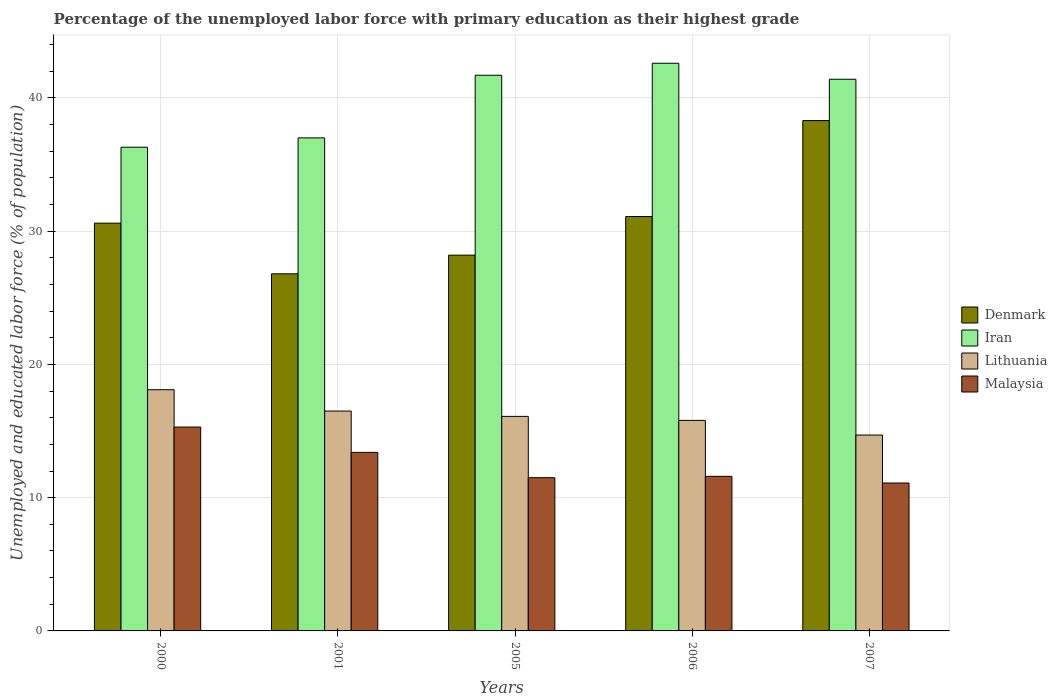How many groups of bars are there?
Your response must be concise. 5. Are the number of bars per tick equal to the number of legend labels?
Give a very brief answer. Yes. How many bars are there on the 4th tick from the left?
Provide a short and direct response. 4. How many bars are there on the 5th tick from the right?
Keep it short and to the point. 4. In how many cases, is the number of bars for a given year not equal to the number of legend labels?
Provide a succinct answer. 0. What is the percentage of the unemployed labor force with primary education in Denmark in 2001?
Give a very brief answer. 26.8. Across all years, what is the maximum percentage of the unemployed labor force with primary education in Malaysia?
Your response must be concise. 15.3. Across all years, what is the minimum percentage of the unemployed labor force with primary education in Iran?
Offer a terse response. 36.3. In which year was the percentage of the unemployed labor force with primary education in Denmark minimum?
Your answer should be very brief. 2001. What is the total percentage of the unemployed labor force with primary education in Denmark in the graph?
Your response must be concise. 155. What is the difference between the percentage of the unemployed labor force with primary education in Lithuania in 2005 and that in 2007?
Offer a very short reply. 1.4. What is the difference between the percentage of the unemployed labor force with primary education in Iran in 2005 and the percentage of the unemployed labor force with primary education in Malaysia in 2001?
Provide a short and direct response. 28.3. What is the average percentage of the unemployed labor force with primary education in Malaysia per year?
Keep it short and to the point. 12.58. In the year 2005, what is the difference between the percentage of the unemployed labor force with primary education in Malaysia and percentage of the unemployed labor force with primary education in Denmark?
Ensure brevity in your answer.  -16.7. What is the ratio of the percentage of the unemployed labor force with primary education in Malaysia in 2006 to that in 2007?
Your answer should be very brief. 1.05. Is the percentage of the unemployed labor force with primary education in Denmark in 2000 less than that in 2001?
Provide a succinct answer. No. What is the difference between the highest and the second highest percentage of the unemployed labor force with primary education in Lithuania?
Your response must be concise. 1.6. What is the difference between the highest and the lowest percentage of the unemployed labor force with primary education in Iran?
Ensure brevity in your answer.  6.3. Is it the case that in every year, the sum of the percentage of the unemployed labor force with primary education in Lithuania and percentage of the unemployed labor force with primary education in Denmark is greater than the sum of percentage of the unemployed labor force with primary education in Malaysia and percentage of the unemployed labor force with primary education in Iran?
Provide a succinct answer. No. What does the 3rd bar from the left in 2006 represents?
Keep it short and to the point. Lithuania. Is it the case that in every year, the sum of the percentage of the unemployed labor force with primary education in Malaysia and percentage of the unemployed labor force with primary education in Lithuania is greater than the percentage of the unemployed labor force with primary education in Denmark?
Offer a terse response. No. Are all the bars in the graph horizontal?
Your response must be concise. No. What is the difference between two consecutive major ticks on the Y-axis?
Offer a terse response. 10. Are the values on the major ticks of Y-axis written in scientific E-notation?
Keep it short and to the point. No. How are the legend labels stacked?
Keep it short and to the point. Vertical. What is the title of the graph?
Keep it short and to the point. Percentage of the unemployed labor force with primary education as their highest grade. Does "Guinea" appear as one of the legend labels in the graph?
Provide a succinct answer. No. What is the label or title of the X-axis?
Give a very brief answer. Years. What is the label or title of the Y-axis?
Give a very brief answer. Unemployed and educated labor force (% of population). What is the Unemployed and educated labor force (% of population) in Denmark in 2000?
Offer a terse response. 30.6. What is the Unemployed and educated labor force (% of population) of Iran in 2000?
Provide a short and direct response. 36.3. What is the Unemployed and educated labor force (% of population) in Lithuania in 2000?
Give a very brief answer. 18.1. What is the Unemployed and educated labor force (% of population) in Malaysia in 2000?
Your answer should be very brief. 15.3. What is the Unemployed and educated labor force (% of population) in Denmark in 2001?
Make the answer very short. 26.8. What is the Unemployed and educated labor force (% of population) of Iran in 2001?
Provide a short and direct response. 37. What is the Unemployed and educated labor force (% of population) in Malaysia in 2001?
Your response must be concise. 13.4. What is the Unemployed and educated labor force (% of population) in Denmark in 2005?
Your response must be concise. 28.2. What is the Unemployed and educated labor force (% of population) of Iran in 2005?
Give a very brief answer. 41.7. What is the Unemployed and educated labor force (% of population) in Lithuania in 2005?
Offer a terse response. 16.1. What is the Unemployed and educated labor force (% of population) of Denmark in 2006?
Your answer should be very brief. 31.1. What is the Unemployed and educated labor force (% of population) in Iran in 2006?
Provide a short and direct response. 42.6. What is the Unemployed and educated labor force (% of population) in Lithuania in 2006?
Provide a succinct answer. 15.8. What is the Unemployed and educated labor force (% of population) in Malaysia in 2006?
Your answer should be very brief. 11.6. What is the Unemployed and educated labor force (% of population) in Denmark in 2007?
Offer a terse response. 38.3. What is the Unemployed and educated labor force (% of population) of Iran in 2007?
Your response must be concise. 41.4. What is the Unemployed and educated labor force (% of population) in Lithuania in 2007?
Provide a succinct answer. 14.7. What is the Unemployed and educated labor force (% of population) of Malaysia in 2007?
Your response must be concise. 11.1. Across all years, what is the maximum Unemployed and educated labor force (% of population) in Denmark?
Provide a succinct answer. 38.3. Across all years, what is the maximum Unemployed and educated labor force (% of population) of Iran?
Your answer should be very brief. 42.6. Across all years, what is the maximum Unemployed and educated labor force (% of population) of Lithuania?
Provide a succinct answer. 18.1. Across all years, what is the maximum Unemployed and educated labor force (% of population) in Malaysia?
Make the answer very short. 15.3. Across all years, what is the minimum Unemployed and educated labor force (% of population) in Denmark?
Your response must be concise. 26.8. Across all years, what is the minimum Unemployed and educated labor force (% of population) in Iran?
Make the answer very short. 36.3. Across all years, what is the minimum Unemployed and educated labor force (% of population) of Lithuania?
Make the answer very short. 14.7. Across all years, what is the minimum Unemployed and educated labor force (% of population) in Malaysia?
Ensure brevity in your answer.  11.1. What is the total Unemployed and educated labor force (% of population) of Denmark in the graph?
Ensure brevity in your answer.  155. What is the total Unemployed and educated labor force (% of population) of Iran in the graph?
Provide a short and direct response. 199. What is the total Unemployed and educated labor force (% of population) of Lithuania in the graph?
Your response must be concise. 81.2. What is the total Unemployed and educated labor force (% of population) in Malaysia in the graph?
Give a very brief answer. 62.9. What is the difference between the Unemployed and educated labor force (% of population) in Lithuania in 2000 and that in 2001?
Provide a short and direct response. 1.6. What is the difference between the Unemployed and educated labor force (% of population) in Malaysia in 2000 and that in 2001?
Make the answer very short. 1.9. What is the difference between the Unemployed and educated labor force (% of population) in Denmark in 2000 and that in 2005?
Provide a short and direct response. 2.4. What is the difference between the Unemployed and educated labor force (% of population) in Malaysia in 2000 and that in 2005?
Make the answer very short. 3.8. What is the difference between the Unemployed and educated labor force (% of population) in Denmark in 2000 and that in 2006?
Provide a short and direct response. -0.5. What is the difference between the Unemployed and educated labor force (% of population) in Iran in 2001 and that in 2005?
Ensure brevity in your answer.  -4.7. What is the difference between the Unemployed and educated labor force (% of population) of Iran in 2001 and that in 2006?
Keep it short and to the point. -5.6. What is the difference between the Unemployed and educated labor force (% of population) of Denmark in 2005 and that in 2006?
Make the answer very short. -2.9. What is the difference between the Unemployed and educated labor force (% of population) in Iran in 2005 and that in 2006?
Offer a very short reply. -0.9. What is the difference between the Unemployed and educated labor force (% of population) of Lithuania in 2005 and that in 2006?
Offer a very short reply. 0.3. What is the difference between the Unemployed and educated labor force (% of population) of Denmark in 2005 and that in 2007?
Keep it short and to the point. -10.1. What is the difference between the Unemployed and educated labor force (% of population) of Iran in 2005 and that in 2007?
Your answer should be compact. 0.3. What is the difference between the Unemployed and educated labor force (% of population) in Lithuania in 2005 and that in 2007?
Your answer should be compact. 1.4. What is the difference between the Unemployed and educated labor force (% of population) in Malaysia in 2005 and that in 2007?
Ensure brevity in your answer.  0.4. What is the difference between the Unemployed and educated labor force (% of population) of Denmark in 2006 and that in 2007?
Provide a short and direct response. -7.2. What is the difference between the Unemployed and educated labor force (% of population) in Denmark in 2000 and the Unemployed and educated labor force (% of population) in Iran in 2001?
Provide a succinct answer. -6.4. What is the difference between the Unemployed and educated labor force (% of population) in Denmark in 2000 and the Unemployed and educated labor force (% of population) in Lithuania in 2001?
Provide a succinct answer. 14.1. What is the difference between the Unemployed and educated labor force (% of population) in Iran in 2000 and the Unemployed and educated labor force (% of population) in Lithuania in 2001?
Offer a very short reply. 19.8. What is the difference between the Unemployed and educated labor force (% of population) in Iran in 2000 and the Unemployed and educated labor force (% of population) in Malaysia in 2001?
Give a very brief answer. 22.9. What is the difference between the Unemployed and educated labor force (% of population) in Denmark in 2000 and the Unemployed and educated labor force (% of population) in Malaysia in 2005?
Provide a succinct answer. 19.1. What is the difference between the Unemployed and educated labor force (% of population) in Iran in 2000 and the Unemployed and educated labor force (% of population) in Lithuania in 2005?
Give a very brief answer. 20.2. What is the difference between the Unemployed and educated labor force (% of population) of Iran in 2000 and the Unemployed and educated labor force (% of population) of Malaysia in 2005?
Your response must be concise. 24.8. What is the difference between the Unemployed and educated labor force (% of population) in Lithuania in 2000 and the Unemployed and educated labor force (% of population) in Malaysia in 2005?
Ensure brevity in your answer.  6.6. What is the difference between the Unemployed and educated labor force (% of population) of Denmark in 2000 and the Unemployed and educated labor force (% of population) of Iran in 2006?
Your answer should be very brief. -12. What is the difference between the Unemployed and educated labor force (% of population) in Denmark in 2000 and the Unemployed and educated labor force (% of population) in Lithuania in 2006?
Offer a very short reply. 14.8. What is the difference between the Unemployed and educated labor force (% of population) of Iran in 2000 and the Unemployed and educated labor force (% of population) of Lithuania in 2006?
Offer a terse response. 20.5. What is the difference between the Unemployed and educated labor force (% of population) of Iran in 2000 and the Unemployed and educated labor force (% of population) of Malaysia in 2006?
Make the answer very short. 24.7. What is the difference between the Unemployed and educated labor force (% of population) in Lithuania in 2000 and the Unemployed and educated labor force (% of population) in Malaysia in 2006?
Provide a short and direct response. 6.5. What is the difference between the Unemployed and educated labor force (% of population) of Iran in 2000 and the Unemployed and educated labor force (% of population) of Lithuania in 2007?
Ensure brevity in your answer.  21.6. What is the difference between the Unemployed and educated labor force (% of population) of Iran in 2000 and the Unemployed and educated labor force (% of population) of Malaysia in 2007?
Ensure brevity in your answer.  25.2. What is the difference between the Unemployed and educated labor force (% of population) in Denmark in 2001 and the Unemployed and educated labor force (% of population) in Iran in 2005?
Your answer should be compact. -14.9. What is the difference between the Unemployed and educated labor force (% of population) in Denmark in 2001 and the Unemployed and educated labor force (% of population) in Lithuania in 2005?
Your answer should be compact. 10.7. What is the difference between the Unemployed and educated labor force (% of population) in Iran in 2001 and the Unemployed and educated labor force (% of population) in Lithuania in 2005?
Offer a very short reply. 20.9. What is the difference between the Unemployed and educated labor force (% of population) of Iran in 2001 and the Unemployed and educated labor force (% of population) of Malaysia in 2005?
Offer a terse response. 25.5. What is the difference between the Unemployed and educated labor force (% of population) in Denmark in 2001 and the Unemployed and educated labor force (% of population) in Iran in 2006?
Provide a succinct answer. -15.8. What is the difference between the Unemployed and educated labor force (% of population) of Denmark in 2001 and the Unemployed and educated labor force (% of population) of Malaysia in 2006?
Provide a succinct answer. 15.2. What is the difference between the Unemployed and educated labor force (% of population) in Iran in 2001 and the Unemployed and educated labor force (% of population) in Lithuania in 2006?
Your response must be concise. 21.2. What is the difference between the Unemployed and educated labor force (% of population) of Iran in 2001 and the Unemployed and educated labor force (% of population) of Malaysia in 2006?
Make the answer very short. 25.4. What is the difference between the Unemployed and educated labor force (% of population) of Lithuania in 2001 and the Unemployed and educated labor force (% of population) of Malaysia in 2006?
Offer a terse response. 4.9. What is the difference between the Unemployed and educated labor force (% of population) of Denmark in 2001 and the Unemployed and educated labor force (% of population) of Iran in 2007?
Ensure brevity in your answer.  -14.6. What is the difference between the Unemployed and educated labor force (% of population) in Denmark in 2001 and the Unemployed and educated labor force (% of population) in Lithuania in 2007?
Provide a short and direct response. 12.1. What is the difference between the Unemployed and educated labor force (% of population) in Iran in 2001 and the Unemployed and educated labor force (% of population) in Lithuania in 2007?
Your answer should be compact. 22.3. What is the difference between the Unemployed and educated labor force (% of population) of Iran in 2001 and the Unemployed and educated labor force (% of population) of Malaysia in 2007?
Offer a very short reply. 25.9. What is the difference between the Unemployed and educated labor force (% of population) in Denmark in 2005 and the Unemployed and educated labor force (% of population) in Iran in 2006?
Ensure brevity in your answer.  -14.4. What is the difference between the Unemployed and educated labor force (% of population) of Denmark in 2005 and the Unemployed and educated labor force (% of population) of Lithuania in 2006?
Keep it short and to the point. 12.4. What is the difference between the Unemployed and educated labor force (% of population) in Denmark in 2005 and the Unemployed and educated labor force (% of population) in Malaysia in 2006?
Keep it short and to the point. 16.6. What is the difference between the Unemployed and educated labor force (% of population) of Iran in 2005 and the Unemployed and educated labor force (% of population) of Lithuania in 2006?
Your answer should be compact. 25.9. What is the difference between the Unemployed and educated labor force (% of population) in Iran in 2005 and the Unemployed and educated labor force (% of population) in Malaysia in 2006?
Your answer should be very brief. 30.1. What is the difference between the Unemployed and educated labor force (% of population) in Iran in 2005 and the Unemployed and educated labor force (% of population) in Lithuania in 2007?
Ensure brevity in your answer.  27. What is the difference between the Unemployed and educated labor force (% of population) in Iran in 2005 and the Unemployed and educated labor force (% of population) in Malaysia in 2007?
Your response must be concise. 30.6. What is the difference between the Unemployed and educated labor force (% of population) in Denmark in 2006 and the Unemployed and educated labor force (% of population) in Lithuania in 2007?
Keep it short and to the point. 16.4. What is the difference between the Unemployed and educated labor force (% of population) in Iran in 2006 and the Unemployed and educated labor force (% of population) in Lithuania in 2007?
Ensure brevity in your answer.  27.9. What is the difference between the Unemployed and educated labor force (% of population) in Iran in 2006 and the Unemployed and educated labor force (% of population) in Malaysia in 2007?
Your response must be concise. 31.5. What is the difference between the Unemployed and educated labor force (% of population) in Lithuania in 2006 and the Unemployed and educated labor force (% of population) in Malaysia in 2007?
Offer a terse response. 4.7. What is the average Unemployed and educated labor force (% of population) in Denmark per year?
Offer a terse response. 31. What is the average Unemployed and educated labor force (% of population) of Iran per year?
Make the answer very short. 39.8. What is the average Unemployed and educated labor force (% of population) of Lithuania per year?
Ensure brevity in your answer.  16.24. What is the average Unemployed and educated labor force (% of population) of Malaysia per year?
Provide a short and direct response. 12.58. In the year 2000, what is the difference between the Unemployed and educated labor force (% of population) in Iran and Unemployed and educated labor force (% of population) in Malaysia?
Offer a terse response. 21. In the year 2001, what is the difference between the Unemployed and educated labor force (% of population) of Denmark and Unemployed and educated labor force (% of population) of Iran?
Your answer should be compact. -10.2. In the year 2001, what is the difference between the Unemployed and educated labor force (% of population) of Denmark and Unemployed and educated labor force (% of population) of Lithuania?
Provide a succinct answer. 10.3. In the year 2001, what is the difference between the Unemployed and educated labor force (% of population) in Iran and Unemployed and educated labor force (% of population) in Malaysia?
Offer a very short reply. 23.6. In the year 2001, what is the difference between the Unemployed and educated labor force (% of population) in Lithuania and Unemployed and educated labor force (% of population) in Malaysia?
Your response must be concise. 3.1. In the year 2005, what is the difference between the Unemployed and educated labor force (% of population) of Iran and Unemployed and educated labor force (% of population) of Lithuania?
Ensure brevity in your answer.  25.6. In the year 2005, what is the difference between the Unemployed and educated labor force (% of population) of Iran and Unemployed and educated labor force (% of population) of Malaysia?
Your response must be concise. 30.2. In the year 2006, what is the difference between the Unemployed and educated labor force (% of population) in Denmark and Unemployed and educated labor force (% of population) in Iran?
Offer a very short reply. -11.5. In the year 2006, what is the difference between the Unemployed and educated labor force (% of population) of Denmark and Unemployed and educated labor force (% of population) of Lithuania?
Your response must be concise. 15.3. In the year 2006, what is the difference between the Unemployed and educated labor force (% of population) of Denmark and Unemployed and educated labor force (% of population) of Malaysia?
Provide a short and direct response. 19.5. In the year 2006, what is the difference between the Unemployed and educated labor force (% of population) of Iran and Unemployed and educated labor force (% of population) of Lithuania?
Your answer should be compact. 26.8. In the year 2006, what is the difference between the Unemployed and educated labor force (% of population) of Iran and Unemployed and educated labor force (% of population) of Malaysia?
Provide a succinct answer. 31. In the year 2007, what is the difference between the Unemployed and educated labor force (% of population) in Denmark and Unemployed and educated labor force (% of population) in Lithuania?
Offer a very short reply. 23.6. In the year 2007, what is the difference between the Unemployed and educated labor force (% of population) of Denmark and Unemployed and educated labor force (% of population) of Malaysia?
Make the answer very short. 27.2. In the year 2007, what is the difference between the Unemployed and educated labor force (% of population) of Iran and Unemployed and educated labor force (% of population) of Lithuania?
Give a very brief answer. 26.7. In the year 2007, what is the difference between the Unemployed and educated labor force (% of population) of Iran and Unemployed and educated labor force (% of population) of Malaysia?
Keep it short and to the point. 30.3. What is the ratio of the Unemployed and educated labor force (% of population) of Denmark in 2000 to that in 2001?
Your response must be concise. 1.14. What is the ratio of the Unemployed and educated labor force (% of population) in Iran in 2000 to that in 2001?
Offer a very short reply. 0.98. What is the ratio of the Unemployed and educated labor force (% of population) in Lithuania in 2000 to that in 2001?
Keep it short and to the point. 1.1. What is the ratio of the Unemployed and educated labor force (% of population) of Malaysia in 2000 to that in 2001?
Your answer should be compact. 1.14. What is the ratio of the Unemployed and educated labor force (% of population) of Denmark in 2000 to that in 2005?
Your response must be concise. 1.09. What is the ratio of the Unemployed and educated labor force (% of population) of Iran in 2000 to that in 2005?
Offer a terse response. 0.87. What is the ratio of the Unemployed and educated labor force (% of population) of Lithuania in 2000 to that in 2005?
Your response must be concise. 1.12. What is the ratio of the Unemployed and educated labor force (% of population) of Malaysia in 2000 to that in 2005?
Your response must be concise. 1.33. What is the ratio of the Unemployed and educated labor force (% of population) of Denmark in 2000 to that in 2006?
Your response must be concise. 0.98. What is the ratio of the Unemployed and educated labor force (% of population) of Iran in 2000 to that in 2006?
Offer a very short reply. 0.85. What is the ratio of the Unemployed and educated labor force (% of population) in Lithuania in 2000 to that in 2006?
Provide a short and direct response. 1.15. What is the ratio of the Unemployed and educated labor force (% of population) of Malaysia in 2000 to that in 2006?
Offer a very short reply. 1.32. What is the ratio of the Unemployed and educated labor force (% of population) in Denmark in 2000 to that in 2007?
Your answer should be compact. 0.8. What is the ratio of the Unemployed and educated labor force (% of population) in Iran in 2000 to that in 2007?
Offer a very short reply. 0.88. What is the ratio of the Unemployed and educated labor force (% of population) in Lithuania in 2000 to that in 2007?
Your answer should be compact. 1.23. What is the ratio of the Unemployed and educated labor force (% of population) in Malaysia in 2000 to that in 2007?
Offer a very short reply. 1.38. What is the ratio of the Unemployed and educated labor force (% of population) in Denmark in 2001 to that in 2005?
Provide a succinct answer. 0.95. What is the ratio of the Unemployed and educated labor force (% of population) of Iran in 2001 to that in 2005?
Give a very brief answer. 0.89. What is the ratio of the Unemployed and educated labor force (% of population) of Lithuania in 2001 to that in 2005?
Offer a terse response. 1.02. What is the ratio of the Unemployed and educated labor force (% of population) of Malaysia in 2001 to that in 2005?
Provide a succinct answer. 1.17. What is the ratio of the Unemployed and educated labor force (% of population) of Denmark in 2001 to that in 2006?
Keep it short and to the point. 0.86. What is the ratio of the Unemployed and educated labor force (% of population) of Iran in 2001 to that in 2006?
Provide a short and direct response. 0.87. What is the ratio of the Unemployed and educated labor force (% of population) of Lithuania in 2001 to that in 2006?
Offer a very short reply. 1.04. What is the ratio of the Unemployed and educated labor force (% of population) in Malaysia in 2001 to that in 2006?
Make the answer very short. 1.16. What is the ratio of the Unemployed and educated labor force (% of population) of Denmark in 2001 to that in 2007?
Give a very brief answer. 0.7. What is the ratio of the Unemployed and educated labor force (% of population) in Iran in 2001 to that in 2007?
Keep it short and to the point. 0.89. What is the ratio of the Unemployed and educated labor force (% of population) of Lithuania in 2001 to that in 2007?
Provide a short and direct response. 1.12. What is the ratio of the Unemployed and educated labor force (% of population) in Malaysia in 2001 to that in 2007?
Provide a short and direct response. 1.21. What is the ratio of the Unemployed and educated labor force (% of population) of Denmark in 2005 to that in 2006?
Ensure brevity in your answer.  0.91. What is the ratio of the Unemployed and educated labor force (% of population) of Iran in 2005 to that in 2006?
Your response must be concise. 0.98. What is the ratio of the Unemployed and educated labor force (% of population) of Denmark in 2005 to that in 2007?
Keep it short and to the point. 0.74. What is the ratio of the Unemployed and educated labor force (% of population) in Iran in 2005 to that in 2007?
Make the answer very short. 1.01. What is the ratio of the Unemployed and educated labor force (% of population) of Lithuania in 2005 to that in 2007?
Provide a short and direct response. 1.1. What is the ratio of the Unemployed and educated labor force (% of population) of Malaysia in 2005 to that in 2007?
Your response must be concise. 1.04. What is the ratio of the Unemployed and educated labor force (% of population) of Denmark in 2006 to that in 2007?
Offer a very short reply. 0.81. What is the ratio of the Unemployed and educated labor force (% of population) of Lithuania in 2006 to that in 2007?
Keep it short and to the point. 1.07. What is the ratio of the Unemployed and educated labor force (% of population) of Malaysia in 2006 to that in 2007?
Ensure brevity in your answer.  1.04. What is the difference between the highest and the second highest Unemployed and educated labor force (% of population) of Iran?
Offer a very short reply. 0.9. What is the difference between the highest and the second highest Unemployed and educated labor force (% of population) of Lithuania?
Keep it short and to the point. 1.6. What is the difference between the highest and the second highest Unemployed and educated labor force (% of population) in Malaysia?
Provide a short and direct response. 1.9. What is the difference between the highest and the lowest Unemployed and educated labor force (% of population) of Denmark?
Ensure brevity in your answer.  11.5. 